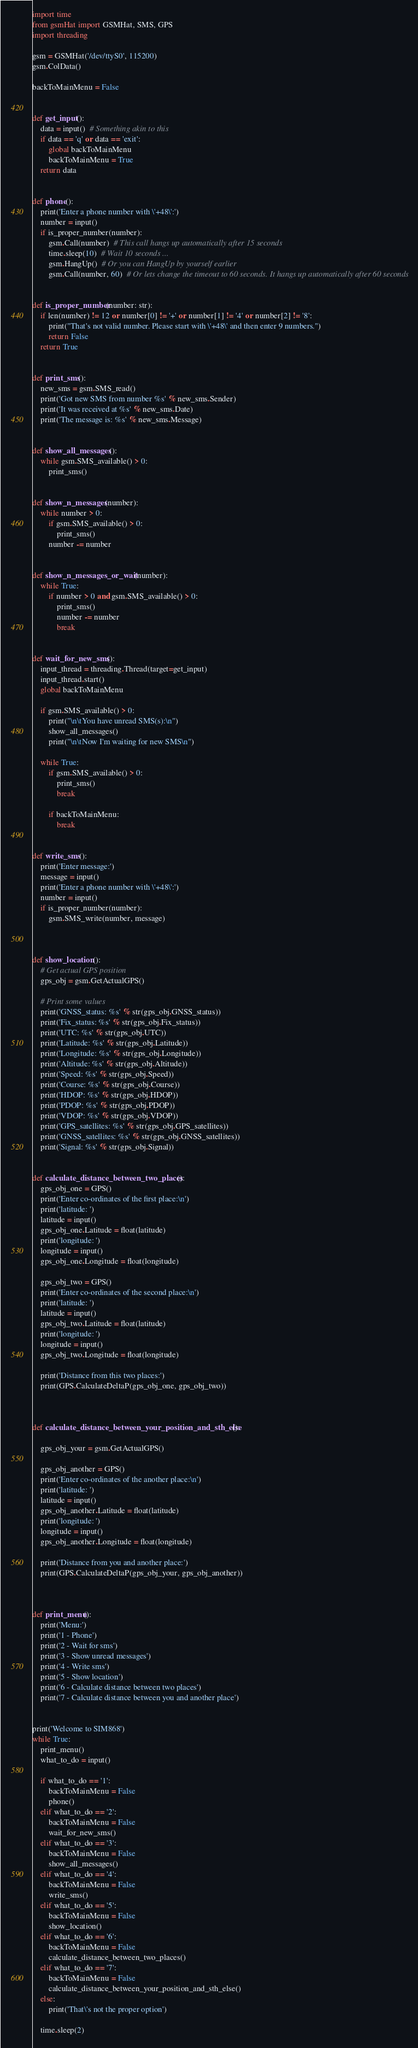<code> <loc_0><loc_0><loc_500><loc_500><_Python_>import time
from gsmHat import GSMHat, SMS, GPS
import threading

gsm = GSMHat('/dev/ttyS0', 115200)
gsm.ColData()

backToMainMenu = False


def get_input():
    data = input()  # Something akin to this
    if data == 'q' or data == 'exit':
        global backToMainMenu
        backToMainMenu = True
    return data


def phone():
    print('Enter a phone number with \'+48\':')
    number = input()
    if is_proper_number(number):
        gsm.Call(number)  # This call hangs up automatically after 15 seconds
        time.sleep(10)  # Wait 10 seconds ...
        gsm.HangUp()  # Or you can HangUp by yourself earlier
        gsm.Call(number, 60)  # Or lets change the timeout to 60 seconds. It hangs up automatically after 60 seconds


def is_proper_number(number: str):
    if len(number) != 12 or number[0] != '+' or number[1] != '4' or number[2] != '8':
        print("That's not valid number. Please start with \'+48\' and then enter 9 numbers.")
        return False
    return True


def print_sms():
    new_sms = gsm.SMS_read()
    print('Got new SMS from number %s' % new_sms.Sender)
    print('It was received at %s' % new_sms.Date)
    print('The message is: %s' % new_sms.Message)


def show_all_messages():
    while gsm.SMS_available() > 0:
        print_sms()


def show_n_messages(number):
    while number > 0:
        if gsm.SMS_available() > 0:
            print_sms()
        number -= number


def show_n_messages_or_wait(number):
    while True:
        if number > 0 and gsm.SMS_available() > 0:
            print_sms()
            number -= number
            break


def wait_for_new_sms():
    input_thread = threading.Thread(target=get_input)
    input_thread.start()
    global backToMainMenu

    if gsm.SMS_available() > 0:
        print("\n\tYou have unread SMS(s):\n")
        show_all_messages()
        print("\n\tNow I'm waiting for new SMS\n")

    while True:
        if gsm.SMS_available() > 0:
            print_sms()
            break

        if backToMainMenu:
            break


def write_sms():
    print('Enter message:')
    message = input()
    print('Enter a phone number with \'+48\':')
    number = input()
    if is_proper_number(number):
        gsm.SMS_write(number, message)



def show_location():
    # Get actual GPS position
    gps_obj = gsm.GetActualGPS()

    # Print some values
    print('GNSS_status: %s' % str(gps_obj.GNSS_status))
    print('Fix_status: %s' % str(gps_obj.Fix_status))
    print('UTC: %s' % str(gps_obj.UTC))
    print('Latitude: %s' % str(gps_obj.Latitude))
    print('Longitude: %s' % str(gps_obj.Longitude))
    print('Altitude: %s' % str(gps_obj.Altitude))
    print('Speed: %s' % str(gps_obj.Speed))
    print('Course: %s' % str(gps_obj.Course))
    print('HDOP: %s' % str(gps_obj.HDOP))
    print('PDOP: %s' % str(gps_obj.PDOP))
    print('VDOP: %s' % str(gps_obj.VDOP))
    print('GPS_satellites: %s' % str(gps_obj.GPS_satellites))
    print('GNSS_satellites: %s' % str(gps_obj.GNSS_satellites))
    print('Signal: %s' % str(gps_obj.Signal))


def calculate_distance_between_two_places():
    gps_obj_one = GPS()
    print('Enter co-ordinates of the first place:\n')
    print('latitude: ')
    latitude = input()
    gps_obj_one.Latitude = float(latitude)
    print('longitude: ')
    longitude = input()
    gps_obj_one.Longitude = float(longitude)

    gps_obj_two = GPS()
    print('Enter co-ordinates of the second place:\n')
    print('latitude: ')
    latitude = input()
    gps_obj_two.Latitude = float(latitude)
    print('longitude: ')
    longitude = input()
    gps_obj_two.Longitude = float(longitude)

    print('Distance from this two places:')
    print(GPS.CalculateDeltaP(gps_obj_one, gps_obj_two))



def calculate_distance_between_your_position_and_sth_else():

    gps_obj_your = gsm.GetActualGPS()

    gps_obj_another = GPS()
    print('Enter co-ordinates of the another place:\n')
    print('latitude: ')
    latitude = input()
    gps_obj_another.Latitude = float(latitude)
    print('longitude: ')
    longitude = input()
    gps_obj_another.Longitude = float(longitude)

    print('Distance from you and another place:')
    print(GPS.CalculateDeltaP(gps_obj_your, gps_obj_another))



def print_menu():
    print('Menu:')
    print('1 - Phone')
    print('2 - Wait for sms')
    print('3 - Show unread messages')
    print('4 - Write sms')
    print('5 - Show location')
    print('6 - Calculate distance between two places')
    print('7 - Calculate distance between you and another place')


print('Welcome to SIM868')
while True:
    print_menu()
    what_to_do = input()

    if what_to_do == '1':
        backToMainMenu = False
        phone()
    elif what_to_do == '2':
        backToMainMenu = False
        wait_for_new_sms()
    elif what_to_do == '3':
        backToMainMenu = False
        show_all_messages()
    elif what_to_do == '4':
        backToMainMenu = False
        write_sms()
    elif what_to_do == '5':
        backToMainMenu = False
        show_location()
    elif what_to_do == '6':
        backToMainMenu = False
        calculate_distance_between_two_places()
    elif what_to_do == '7':
        backToMainMenu = False
        calculate_distance_between_your_position_and_sth_else()
    else:
        print('That\'s not the proper option')

    time.sleep(2)
</code> 